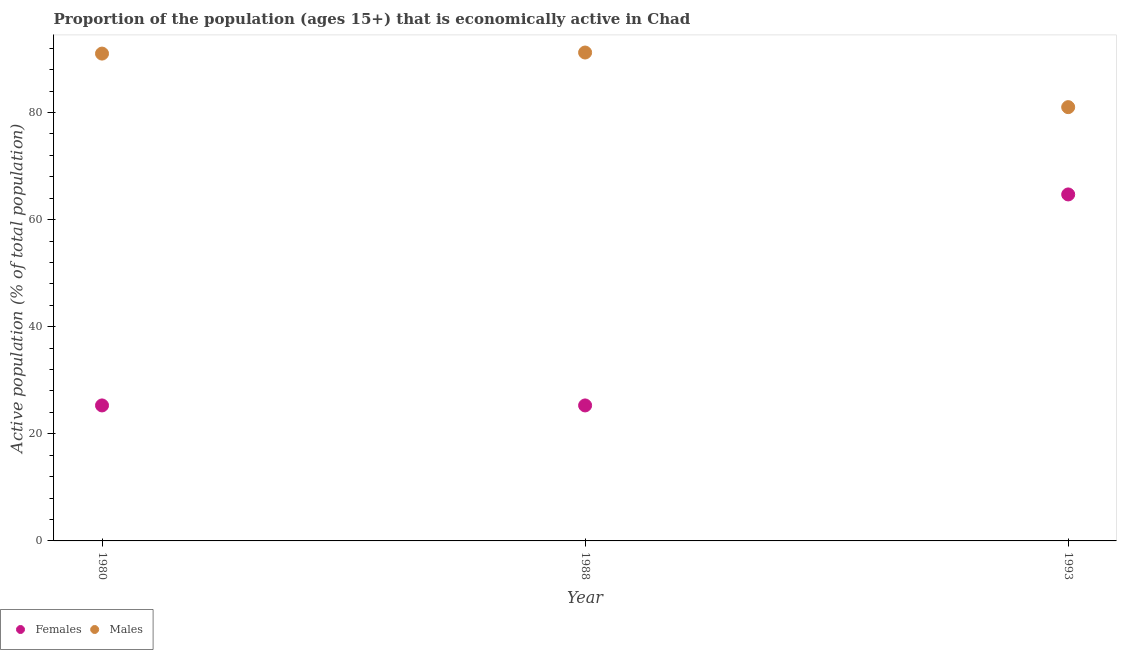What is the percentage of economically active male population in 1980?
Your response must be concise. 91. Across all years, what is the maximum percentage of economically active female population?
Give a very brief answer. 64.7. Across all years, what is the minimum percentage of economically active female population?
Your answer should be very brief. 25.3. In which year was the percentage of economically active female population minimum?
Give a very brief answer. 1980. What is the total percentage of economically active male population in the graph?
Keep it short and to the point. 263.2. What is the difference between the percentage of economically active female population in 1988 and the percentage of economically active male population in 1993?
Ensure brevity in your answer.  -55.7. What is the average percentage of economically active female population per year?
Ensure brevity in your answer.  38.43. In the year 1993, what is the difference between the percentage of economically active female population and percentage of economically active male population?
Make the answer very short. -16.3. In how many years, is the percentage of economically active female population greater than 84 %?
Your answer should be very brief. 0. Is the percentage of economically active male population in 1980 less than that in 1993?
Offer a very short reply. No. Is the difference between the percentage of economically active male population in 1980 and 1993 greater than the difference between the percentage of economically active female population in 1980 and 1993?
Provide a succinct answer. Yes. What is the difference between the highest and the second highest percentage of economically active female population?
Your answer should be compact. 39.4. What is the difference between the highest and the lowest percentage of economically active male population?
Offer a terse response. 10.2. In how many years, is the percentage of economically active female population greater than the average percentage of economically active female population taken over all years?
Your answer should be compact. 1. Is the sum of the percentage of economically active female population in 1980 and 1993 greater than the maximum percentage of economically active male population across all years?
Keep it short and to the point. No. Does the percentage of economically active male population monotonically increase over the years?
Provide a short and direct response. No. Is the percentage of economically active male population strictly greater than the percentage of economically active female population over the years?
Give a very brief answer. Yes. How many dotlines are there?
Provide a short and direct response. 2. How many years are there in the graph?
Your answer should be very brief. 3. Does the graph contain any zero values?
Provide a short and direct response. No. Where does the legend appear in the graph?
Make the answer very short. Bottom left. How many legend labels are there?
Your response must be concise. 2. What is the title of the graph?
Offer a very short reply. Proportion of the population (ages 15+) that is economically active in Chad. Does "Secondary school" appear as one of the legend labels in the graph?
Offer a very short reply. No. What is the label or title of the Y-axis?
Offer a terse response. Active population (% of total population). What is the Active population (% of total population) of Females in 1980?
Provide a short and direct response. 25.3. What is the Active population (% of total population) in Males in 1980?
Ensure brevity in your answer.  91. What is the Active population (% of total population) of Females in 1988?
Keep it short and to the point. 25.3. What is the Active population (% of total population) of Males in 1988?
Ensure brevity in your answer.  91.2. What is the Active population (% of total population) of Females in 1993?
Your response must be concise. 64.7. Across all years, what is the maximum Active population (% of total population) of Females?
Your answer should be very brief. 64.7. Across all years, what is the maximum Active population (% of total population) in Males?
Your answer should be very brief. 91.2. Across all years, what is the minimum Active population (% of total population) in Females?
Your answer should be compact. 25.3. Across all years, what is the minimum Active population (% of total population) of Males?
Offer a very short reply. 81. What is the total Active population (% of total population) in Females in the graph?
Keep it short and to the point. 115.3. What is the total Active population (% of total population) in Males in the graph?
Offer a terse response. 263.2. What is the difference between the Active population (% of total population) of Females in 1980 and that in 1988?
Your response must be concise. 0. What is the difference between the Active population (% of total population) of Females in 1980 and that in 1993?
Provide a short and direct response. -39.4. What is the difference between the Active population (% of total population) of Females in 1988 and that in 1993?
Give a very brief answer. -39.4. What is the difference between the Active population (% of total population) in Males in 1988 and that in 1993?
Provide a short and direct response. 10.2. What is the difference between the Active population (% of total population) in Females in 1980 and the Active population (% of total population) in Males in 1988?
Give a very brief answer. -65.9. What is the difference between the Active population (% of total population) in Females in 1980 and the Active population (% of total population) in Males in 1993?
Offer a terse response. -55.7. What is the difference between the Active population (% of total population) of Females in 1988 and the Active population (% of total population) of Males in 1993?
Keep it short and to the point. -55.7. What is the average Active population (% of total population) of Females per year?
Provide a short and direct response. 38.43. What is the average Active population (% of total population) of Males per year?
Make the answer very short. 87.73. In the year 1980, what is the difference between the Active population (% of total population) in Females and Active population (% of total population) in Males?
Make the answer very short. -65.7. In the year 1988, what is the difference between the Active population (% of total population) of Females and Active population (% of total population) of Males?
Your answer should be compact. -65.9. In the year 1993, what is the difference between the Active population (% of total population) in Females and Active population (% of total population) in Males?
Make the answer very short. -16.3. What is the ratio of the Active population (% of total population) of Females in 1980 to that in 1988?
Offer a terse response. 1. What is the ratio of the Active population (% of total population) of Females in 1980 to that in 1993?
Keep it short and to the point. 0.39. What is the ratio of the Active population (% of total population) of Males in 1980 to that in 1993?
Make the answer very short. 1.12. What is the ratio of the Active population (% of total population) of Females in 1988 to that in 1993?
Your answer should be very brief. 0.39. What is the ratio of the Active population (% of total population) in Males in 1988 to that in 1993?
Make the answer very short. 1.13. What is the difference between the highest and the second highest Active population (% of total population) in Females?
Your response must be concise. 39.4. What is the difference between the highest and the second highest Active population (% of total population) of Males?
Your answer should be compact. 0.2. What is the difference between the highest and the lowest Active population (% of total population) of Females?
Your answer should be compact. 39.4. 